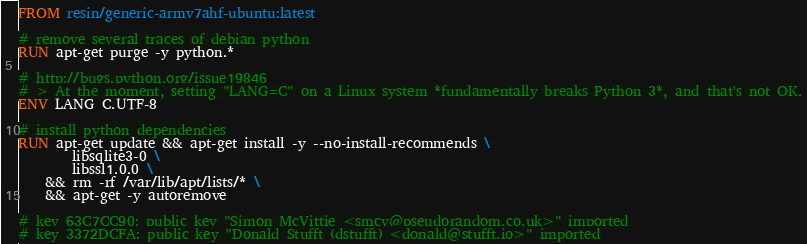Convert code to text. <code><loc_0><loc_0><loc_500><loc_500><_Dockerfile_>FROM resin/generic-armv7ahf-ubuntu:latest

# remove several traces of debian python
RUN apt-get purge -y python.*

# http://bugs.python.org/issue19846
# > At the moment, setting "LANG=C" on a Linux system *fundamentally breaks Python 3*, and that's not OK.
ENV LANG C.UTF-8

# install python dependencies
RUN apt-get update && apt-get install -y --no-install-recommends \
		libsqlite3-0 \
		libssl1.0.0 \
	&& rm -rf /var/lib/apt/lists/* \
	&& apt-get -y autoremove

# key 63C7CC90: public key "Simon McVittie <smcv@pseudorandom.co.uk>" imported
# key 3372DCFA: public key "Donald Stufft (dstufft) <donald@stufft.io>" imported</code> 